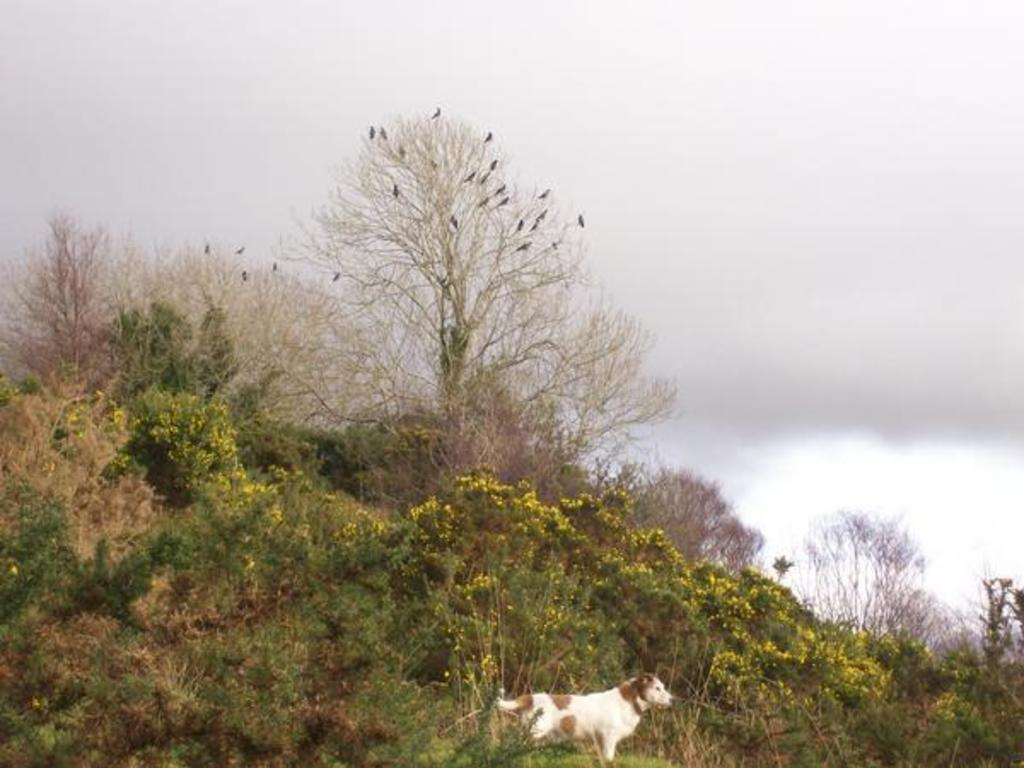What type of natural elements can be seen in the image? There are many trees and plants in the image. What type of animal is present in the image? There is a dog in the image. What can be seen in the sky in the image? There are clouds in the sky. Where is the alley located in the image? There is no alley present in the image. What type of container is the dog holding in the image? There is no container, such as a basket, visible in the image. 